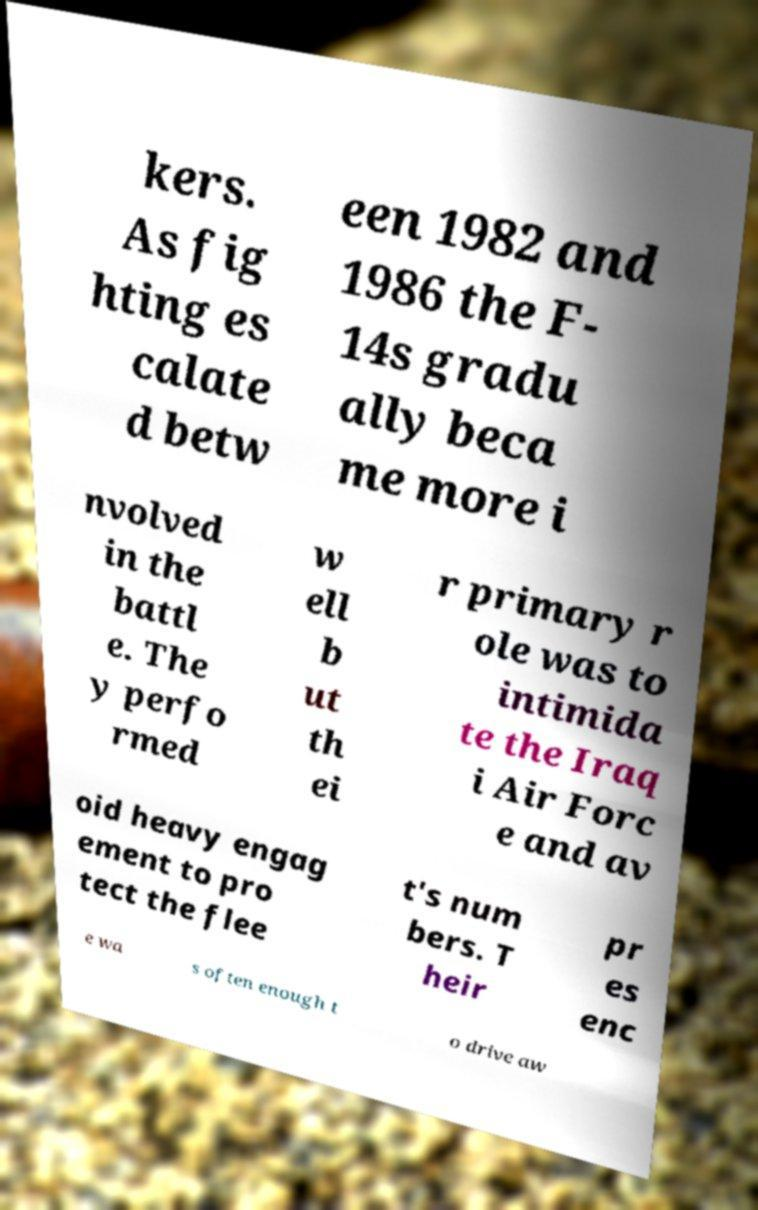Can you accurately transcribe the text from the provided image for me? kers. As fig hting es calate d betw een 1982 and 1986 the F- 14s gradu ally beca me more i nvolved in the battl e. The y perfo rmed w ell b ut th ei r primary r ole was to intimida te the Iraq i Air Forc e and av oid heavy engag ement to pro tect the flee t's num bers. T heir pr es enc e wa s often enough t o drive aw 